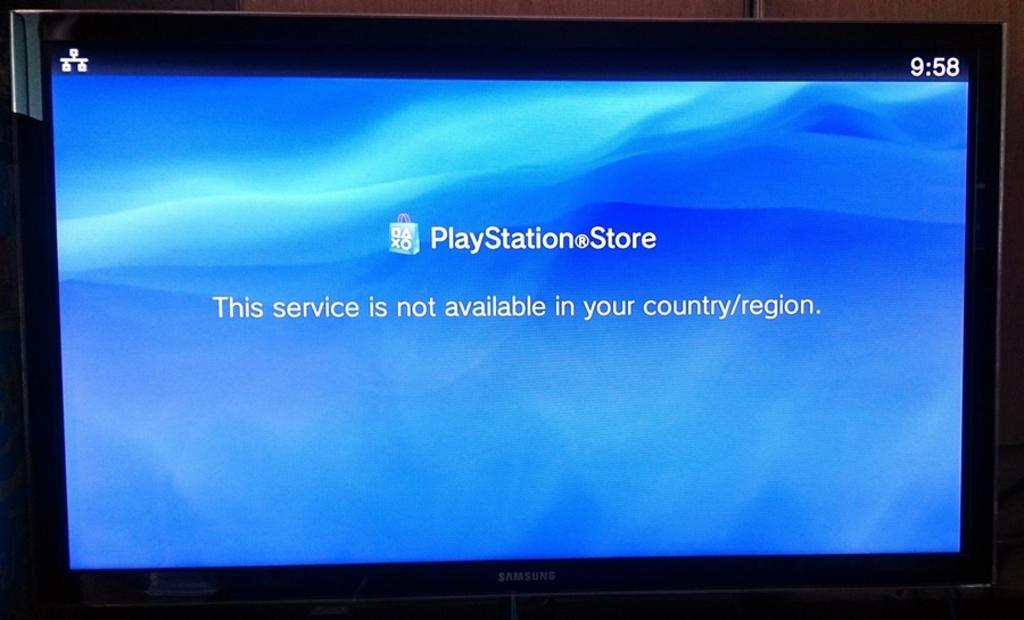<image>
Share a concise interpretation of the image provided. A screen is showing that the PlayStation Store is not available in your country. 